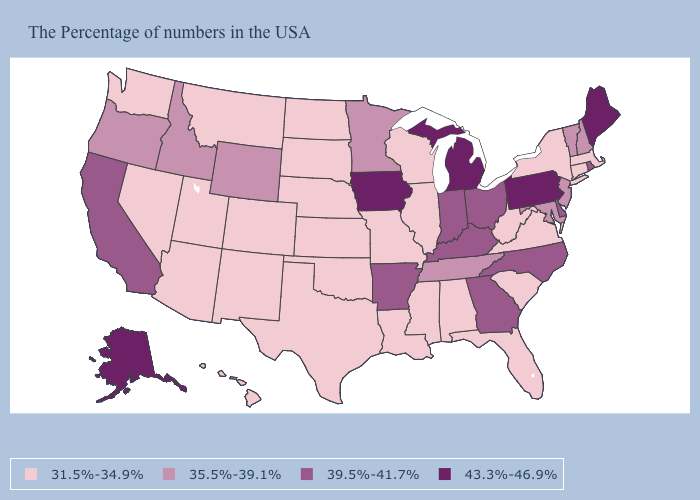Does Idaho have the lowest value in the USA?
Be succinct. No. Among the states that border California , does Oregon have the highest value?
Be succinct. Yes. Which states have the highest value in the USA?
Concise answer only. Maine, Pennsylvania, Michigan, Iowa, Alaska. What is the value of Illinois?
Be succinct. 31.5%-34.9%. What is the highest value in the South ?
Write a very short answer. 39.5%-41.7%. What is the lowest value in the USA?
Be succinct. 31.5%-34.9%. What is the highest value in the Northeast ?
Give a very brief answer. 43.3%-46.9%. Does Oregon have the lowest value in the USA?
Short answer required. No. Which states hav the highest value in the Northeast?
Short answer required. Maine, Pennsylvania. Which states have the lowest value in the West?
Short answer required. Colorado, New Mexico, Utah, Montana, Arizona, Nevada, Washington, Hawaii. Does Pennsylvania have a lower value than South Carolina?
Answer briefly. No. Does Minnesota have the highest value in the USA?
Concise answer only. No. Does Tennessee have the lowest value in the South?
Be succinct. No. Among the states that border Colorado , which have the lowest value?
Concise answer only. Kansas, Nebraska, Oklahoma, New Mexico, Utah, Arizona. What is the value of Texas?
Be succinct. 31.5%-34.9%. 